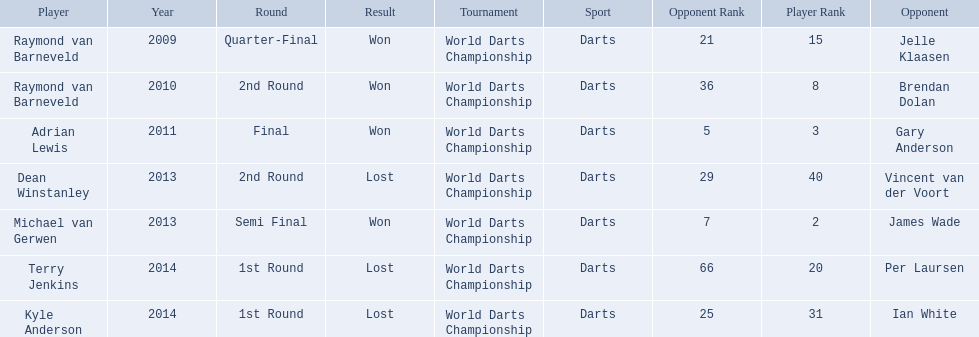Who were all the players? Raymond van Barneveld, Raymond van Barneveld, Adrian Lewis, Dean Winstanley, Michael van Gerwen, Terry Jenkins, Kyle Anderson. Which of these played in 2014? Terry Jenkins, Kyle Anderson. Who were their opponents? Per Laursen, Ian White. Which of these beat terry jenkins? Per Laursen. 